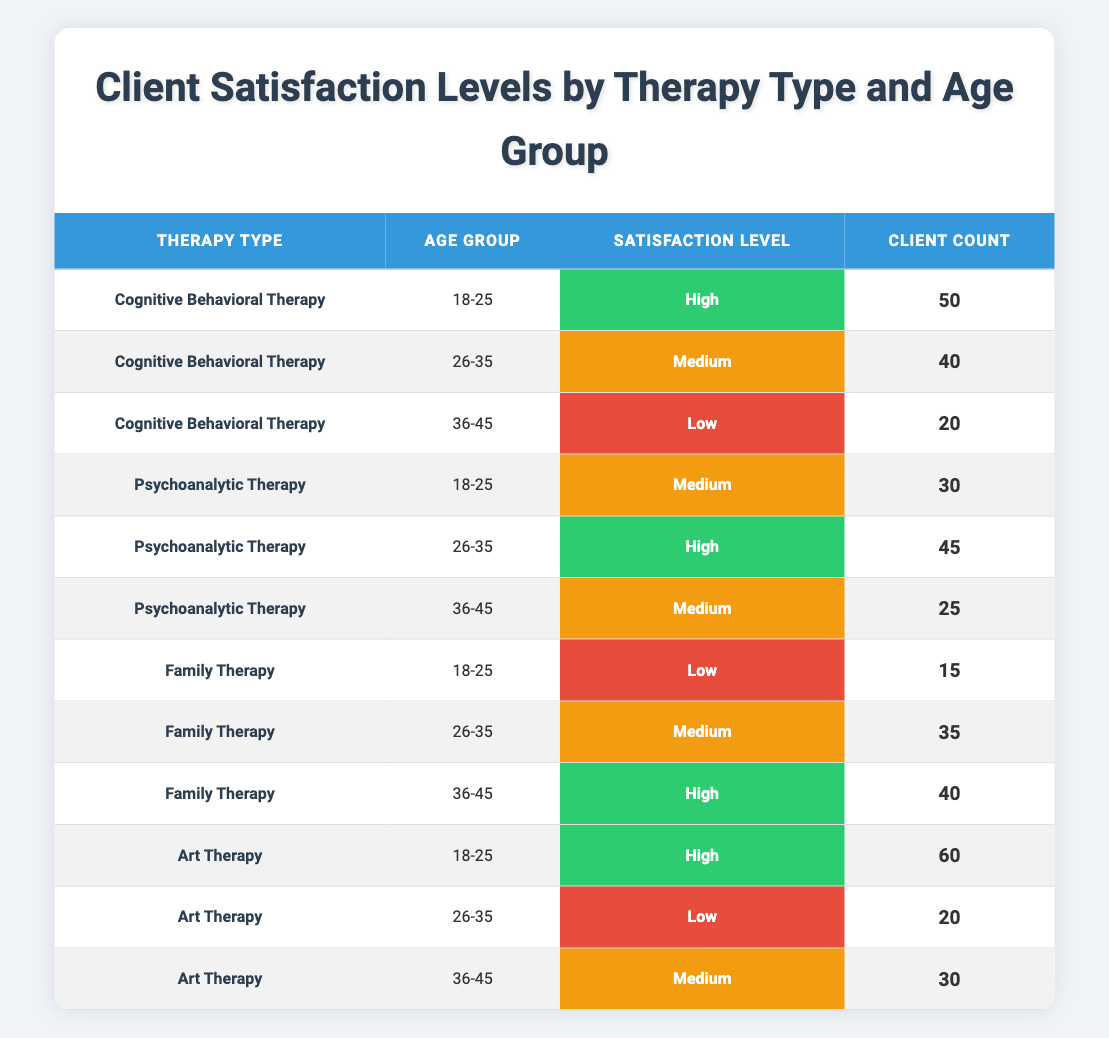What is the highest client count in the table? By examining the table, I see that Art Therapy for the age group 18-25 has the highest client count of 60.
Answer: 60 Which therapy type has the lowest satisfaction level in the age group 36-45? In the age group 36-45, Cognitive Behavioral Therapy has a low satisfaction level among the listed therapies.
Answer: Cognitive Behavioral Therapy True or False: Family Therapy has a high satisfaction level among clients aged 18-25. According to the table, Family Therapy for the age group 18-25 has a low satisfaction level, making this statement false.
Answer: False What is the total client count for Psychoanalytic Therapy across all age groups? Summing the client counts for Psychoanalytic Therapy from the table: 30 (age 18-25) + 45 (age 26-35) + 25 (age 36-45) = 100.
Answer: 100 Which age group shows the highest satisfaction level for Cognitive Behavioral Therapy, and what is that level? The age group 18-25 displays the highest satisfaction level of high for Cognitive Behavioral Therapy, as indicated in the table.
Answer: High How many clients reported a low satisfaction level across all therapy types? To find this, I need to count the clients with low satisfaction: 20 (Cognitive Behavioral Therapy, 36-45) + 15 (Family Therapy, 18-25) + 20 (Art Therapy, 26-35) = 55. Thus, there are 55 clients who reported low satisfaction across the mentioned therapy types.
Answer: 55 Which demographic factor shows the highest number of satisfied clients? Assessing each age group for the highest counted satisfaction level, the age group 18-25 with Art Therapy has 60 clients counting high satisfaction. Therefore, 18-25 shows the highest satisfaction.
Answer: Age Group 18-25 Does Family Therapy have any demographic group with a satisfaction level categorized as medium? The table shows that Family Therapy for the age group 26-35 has a medium satisfaction level, therefore confirming that the statement is true.
Answer: True 